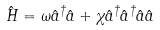<formula> <loc_0><loc_0><loc_500><loc_500>\hat { H } = \omega \hat { a } ^ { \dagger } \hat { a } + \chi \hat { a } ^ { \dagger } \hat { a } ^ { \dagger } \hat { a } \hat { a }</formula> 